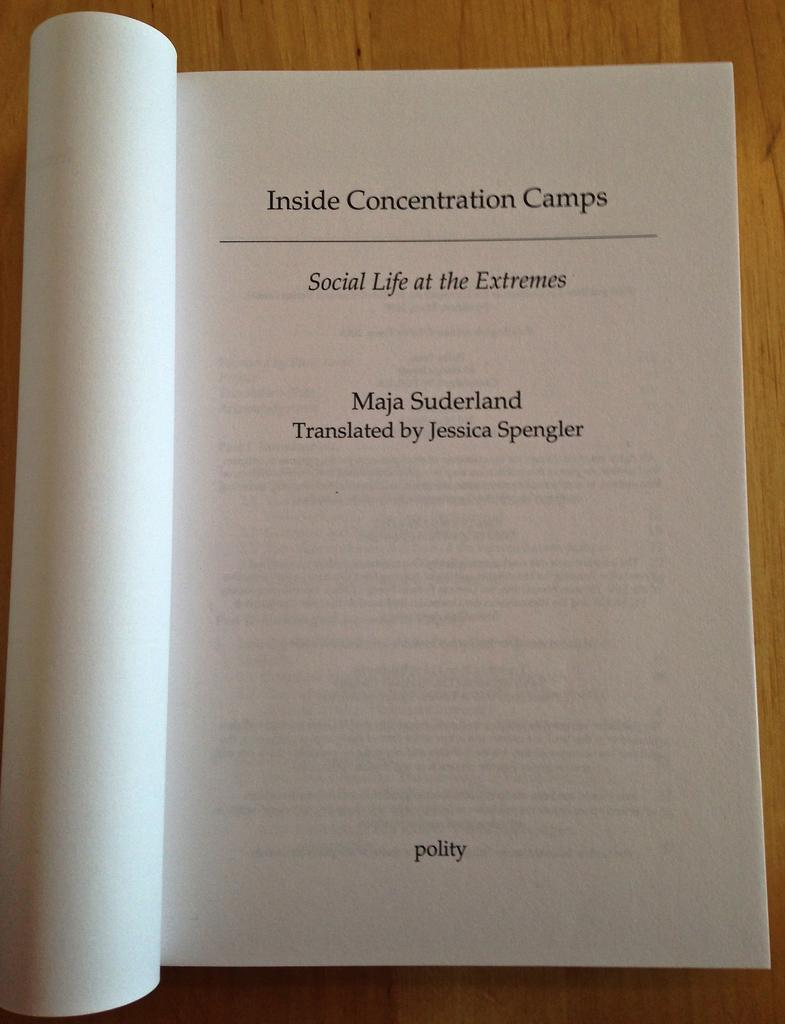<image>
Write a terse but informative summary of the picture. The book Inside Concentration Camps, Social LIfe at the Extremes is open on a table. 